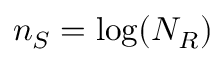Convert formula to latex. <formula><loc_0><loc_0><loc_500><loc_500>n _ { S } = \log ( N _ { R } )</formula> 